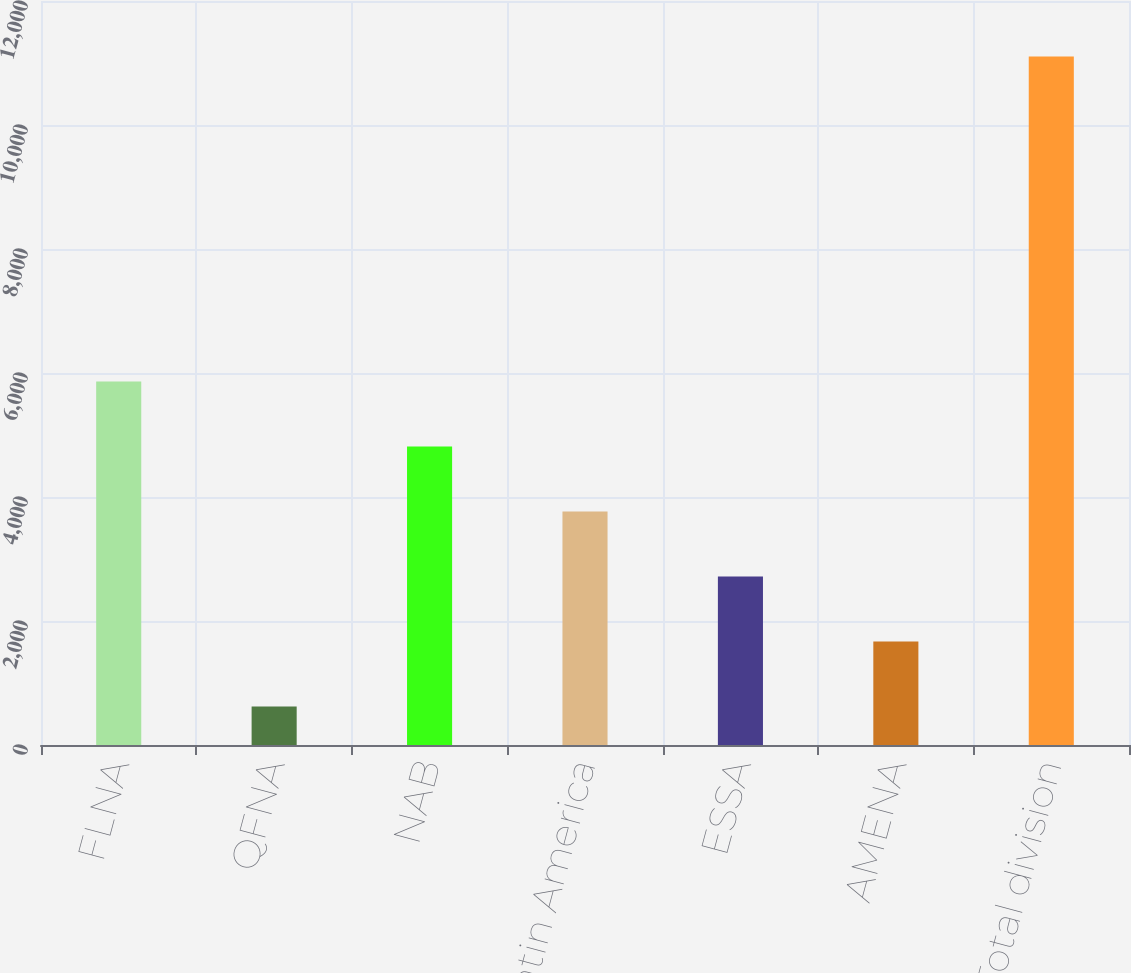Convert chart to OTSL. <chart><loc_0><loc_0><loc_500><loc_500><bar_chart><fcel>FLNA<fcel>QFNA<fcel>NAB<fcel>Latin America<fcel>ESSA<fcel>AMENA<fcel>Total division<nl><fcel>5863.5<fcel>621<fcel>4815<fcel>3766.5<fcel>2718<fcel>1669.5<fcel>11106<nl></chart> 